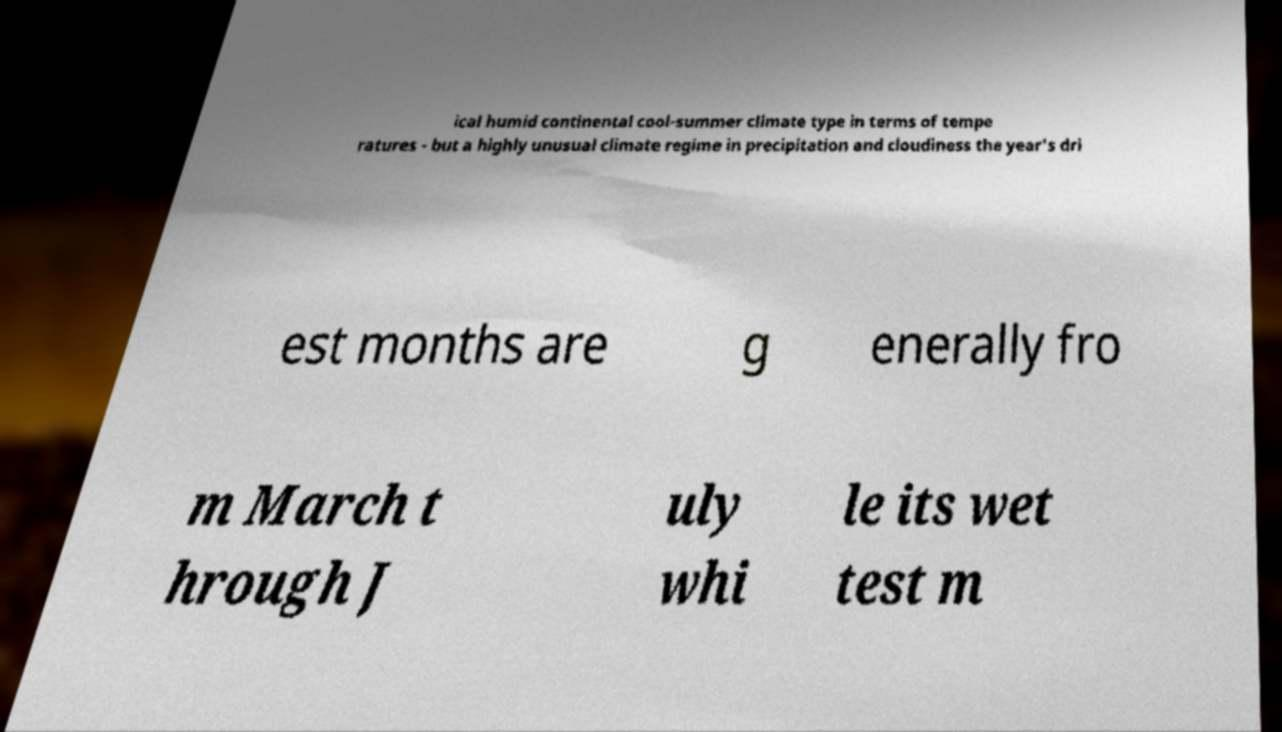There's text embedded in this image that I need extracted. Can you transcribe it verbatim? ical humid continental cool-summer climate type in terms of tempe ratures - but a highly unusual climate regime in precipitation and cloudiness the year's dri est months are g enerally fro m March t hrough J uly whi le its wet test m 